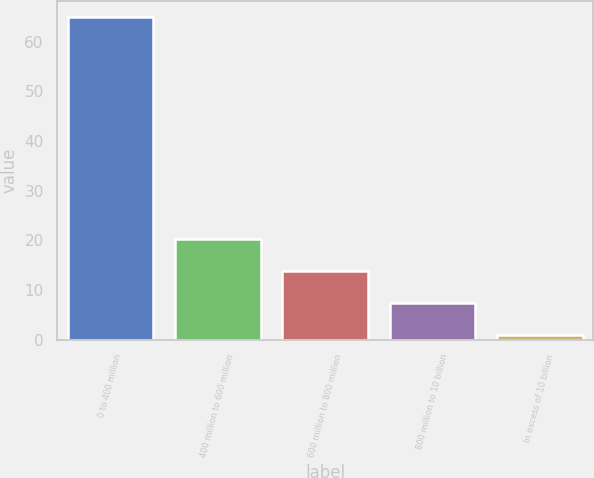Convert chart. <chart><loc_0><loc_0><loc_500><loc_500><bar_chart><fcel>0 to 400 million<fcel>400 million to 600 million<fcel>600 million to 800 million<fcel>800 million to 10 billion<fcel>In excess of 10 billion<nl><fcel>65<fcel>20.2<fcel>13.8<fcel>7.4<fcel>1<nl></chart> 